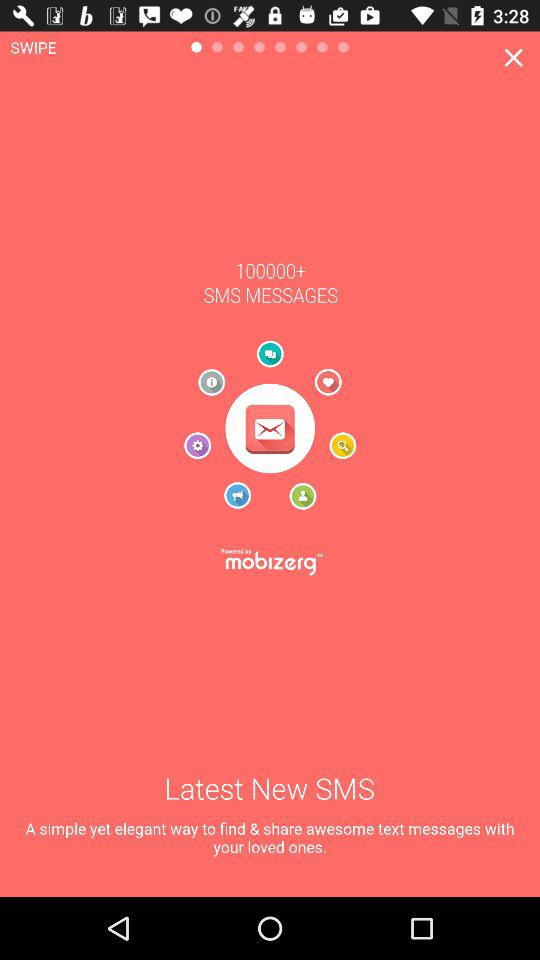What is the count of messages?
When the provided information is insufficient, respond with <no answer>. <no answer> 